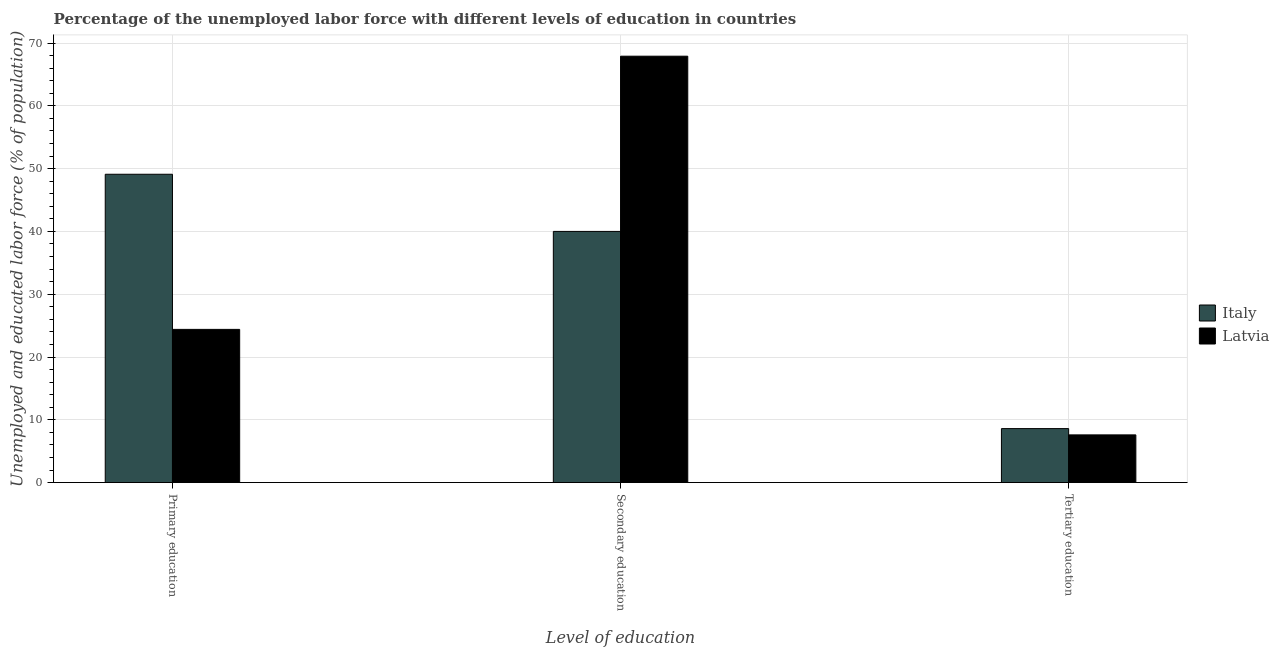How many different coloured bars are there?
Your answer should be very brief. 2. How many groups of bars are there?
Make the answer very short. 3. Are the number of bars on each tick of the X-axis equal?
Keep it short and to the point. Yes. How many bars are there on the 1st tick from the left?
Your response must be concise. 2. How many bars are there on the 2nd tick from the right?
Keep it short and to the point. 2. What is the label of the 2nd group of bars from the left?
Provide a succinct answer. Secondary education. What is the percentage of labor force who received secondary education in Italy?
Make the answer very short. 40. Across all countries, what is the maximum percentage of labor force who received primary education?
Make the answer very short. 49.1. Across all countries, what is the minimum percentage of labor force who received secondary education?
Give a very brief answer. 40. In which country was the percentage of labor force who received primary education maximum?
Make the answer very short. Italy. In which country was the percentage of labor force who received primary education minimum?
Give a very brief answer. Latvia. What is the total percentage of labor force who received tertiary education in the graph?
Offer a terse response. 16.2. What is the difference between the percentage of labor force who received primary education in Italy and that in Latvia?
Give a very brief answer. 24.7. What is the difference between the percentage of labor force who received secondary education in Latvia and the percentage of labor force who received primary education in Italy?
Provide a short and direct response. 18.8. What is the average percentage of labor force who received primary education per country?
Offer a terse response. 36.75. What is the difference between the percentage of labor force who received secondary education and percentage of labor force who received primary education in Italy?
Provide a succinct answer. -9.1. What is the ratio of the percentage of labor force who received tertiary education in Latvia to that in Italy?
Provide a short and direct response. 0.88. Is the percentage of labor force who received tertiary education in Italy less than that in Latvia?
Offer a terse response. No. What is the difference between the highest and the second highest percentage of labor force who received primary education?
Provide a short and direct response. 24.7. What is the difference between the highest and the lowest percentage of labor force who received primary education?
Provide a succinct answer. 24.7. What does the 2nd bar from the right in Primary education represents?
Offer a terse response. Italy. Is it the case that in every country, the sum of the percentage of labor force who received primary education and percentage of labor force who received secondary education is greater than the percentage of labor force who received tertiary education?
Give a very brief answer. Yes. Are the values on the major ticks of Y-axis written in scientific E-notation?
Offer a terse response. No. Does the graph contain grids?
Ensure brevity in your answer.  Yes. How are the legend labels stacked?
Give a very brief answer. Vertical. What is the title of the graph?
Offer a very short reply. Percentage of the unemployed labor force with different levels of education in countries. What is the label or title of the X-axis?
Offer a very short reply. Level of education. What is the label or title of the Y-axis?
Keep it short and to the point. Unemployed and educated labor force (% of population). What is the Unemployed and educated labor force (% of population) in Italy in Primary education?
Make the answer very short. 49.1. What is the Unemployed and educated labor force (% of population) of Latvia in Primary education?
Your answer should be very brief. 24.4. What is the Unemployed and educated labor force (% of population) of Latvia in Secondary education?
Offer a very short reply. 67.9. What is the Unemployed and educated labor force (% of population) of Italy in Tertiary education?
Ensure brevity in your answer.  8.6. What is the Unemployed and educated labor force (% of population) of Latvia in Tertiary education?
Provide a succinct answer. 7.6. Across all Level of education, what is the maximum Unemployed and educated labor force (% of population) in Italy?
Give a very brief answer. 49.1. Across all Level of education, what is the maximum Unemployed and educated labor force (% of population) of Latvia?
Offer a terse response. 67.9. Across all Level of education, what is the minimum Unemployed and educated labor force (% of population) in Italy?
Give a very brief answer. 8.6. Across all Level of education, what is the minimum Unemployed and educated labor force (% of population) in Latvia?
Offer a terse response. 7.6. What is the total Unemployed and educated labor force (% of population) of Italy in the graph?
Offer a terse response. 97.7. What is the total Unemployed and educated labor force (% of population) in Latvia in the graph?
Your answer should be very brief. 99.9. What is the difference between the Unemployed and educated labor force (% of population) of Latvia in Primary education and that in Secondary education?
Offer a very short reply. -43.5. What is the difference between the Unemployed and educated labor force (% of population) in Italy in Primary education and that in Tertiary education?
Your answer should be very brief. 40.5. What is the difference between the Unemployed and educated labor force (% of population) of Italy in Secondary education and that in Tertiary education?
Your answer should be compact. 31.4. What is the difference between the Unemployed and educated labor force (% of population) in Latvia in Secondary education and that in Tertiary education?
Your answer should be very brief. 60.3. What is the difference between the Unemployed and educated labor force (% of population) of Italy in Primary education and the Unemployed and educated labor force (% of population) of Latvia in Secondary education?
Your answer should be compact. -18.8. What is the difference between the Unemployed and educated labor force (% of population) in Italy in Primary education and the Unemployed and educated labor force (% of population) in Latvia in Tertiary education?
Make the answer very short. 41.5. What is the difference between the Unemployed and educated labor force (% of population) of Italy in Secondary education and the Unemployed and educated labor force (% of population) of Latvia in Tertiary education?
Your response must be concise. 32.4. What is the average Unemployed and educated labor force (% of population) of Italy per Level of education?
Offer a terse response. 32.57. What is the average Unemployed and educated labor force (% of population) of Latvia per Level of education?
Keep it short and to the point. 33.3. What is the difference between the Unemployed and educated labor force (% of population) in Italy and Unemployed and educated labor force (% of population) in Latvia in Primary education?
Your response must be concise. 24.7. What is the difference between the Unemployed and educated labor force (% of population) of Italy and Unemployed and educated labor force (% of population) of Latvia in Secondary education?
Provide a short and direct response. -27.9. What is the difference between the Unemployed and educated labor force (% of population) of Italy and Unemployed and educated labor force (% of population) of Latvia in Tertiary education?
Your answer should be very brief. 1. What is the ratio of the Unemployed and educated labor force (% of population) of Italy in Primary education to that in Secondary education?
Give a very brief answer. 1.23. What is the ratio of the Unemployed and educated labor force (% of population) in Latvia in Primary education to that in Secondary education?
Provide a succinct answer. 0.36. What is the ratio of the Unemployed and educated labor force (% of population) in Italy in Primary education to that in Tertiary education?
Make the answer very short. 5.71. What is the ratio of the Unemployed and educated labor force (% of population) in Latvia in Primary education to that in Tertiary education?
Offer a very short reply. 3.21. What is the ratio of the Unemployed and educated labor force (% of population) in Italy in Secondary education to that in Tertiary education?
Your response must be concise. 4.65. What is the ratio of the Unemployed and educated labor force (% of population) in Latvia in Secondary education to that in Tertiary education?
Your response must be concise. 8.93. What is the difference between the highest and the second highest Unemployed and educated labor force (% of population) of Italy?
Ensure brevity in your answer.  9.1. What is the difference between the highest and the second highest Unemployed and educated labor force (% of population) of Latvia?
Keep it short and to the point. 43.5. What is the difference between the highest and the lowest Unemployed and educated labor force (% of population) in Italy?
Provide a short and direct response. 40.5. What is the difference between the highest and the lowest Unemployed and educated labor force (% of population) of Latvia?
Ensure brevity in your answer.  60.3. 